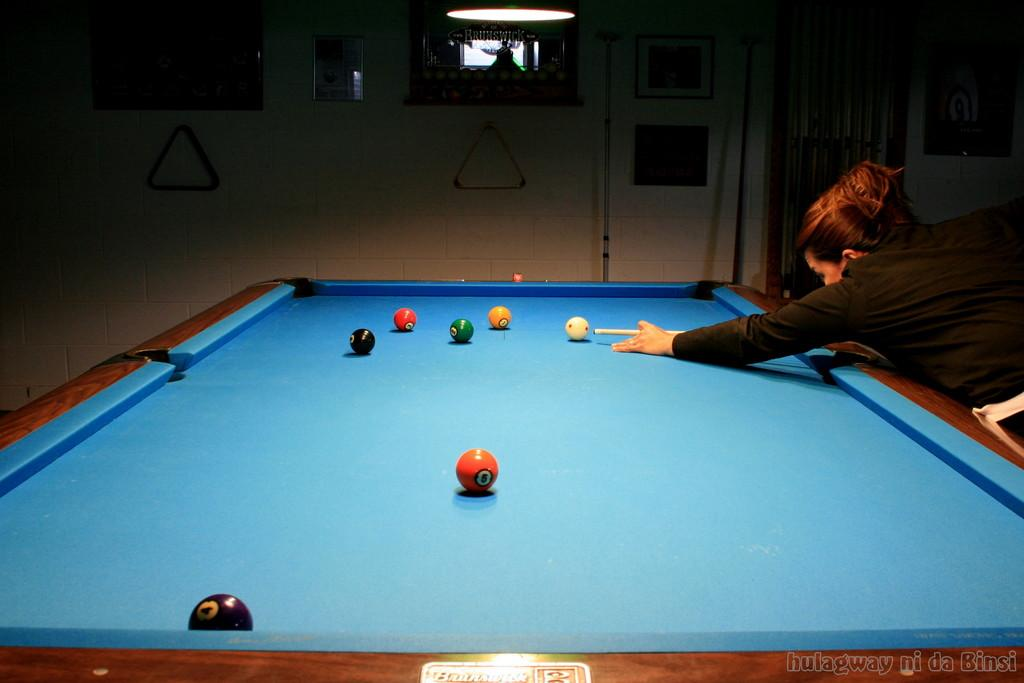What game is being played in the image? The image features a snooker board, so the game being played is likely snooker. What objects are on the snooker board? There are balls on the snooker board. What is the woman in the image using to interact with the snooker board? The woman is playing with a stick, which is likely a snooker cue. What can be seen in the background of the image? There is a wall in the background of the image. What type of brush is being used to paint the group of people in the image? There is no brush or group of people present in the image; it features a snooker board and a woman playing with a snooker cue. 